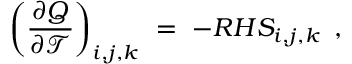Convert formula to latex. <formula><loc_0><loc_0><loc_500><loc_500>\left ( \frac { \partial Q } { \partial \mathcal { T } } \right ) _ { i , j , k } \ = \ - R H S _ { i , j , k } \, ,</formula> 